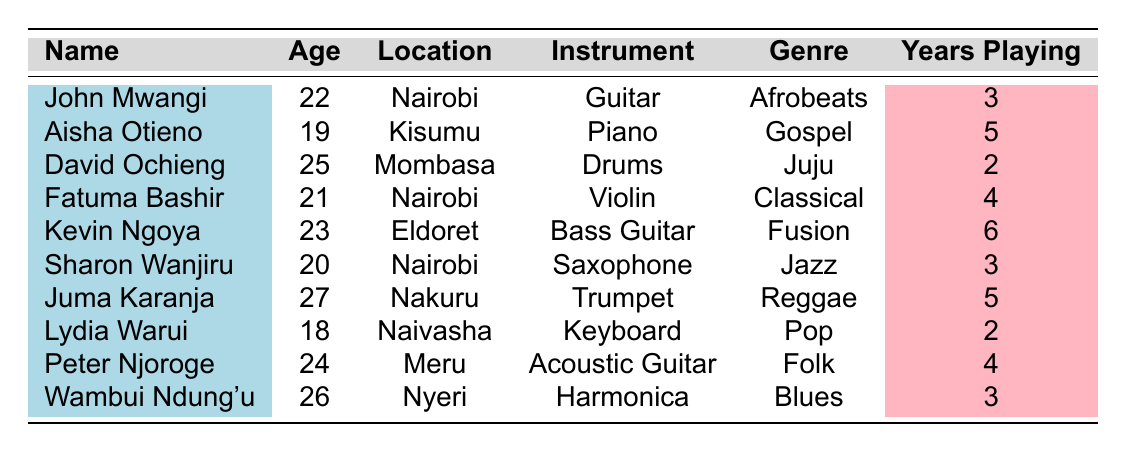What's the most common instrument among amateur musicians listed? By looking at the table, each musician's instrument is identified. The unique instruments mentioned are Guitar, Piano, Drums, Violin, Bass Guitar, Saxophone, Trumpet, Keyboard, Acoustic Guitar, and Harmonica. No instrument is repeated, so none can be deemed common.
Answer: No common instrument What is the age of the youngest musician? The ages of all musicians are listed. The youngest musician is Lydia Warui, who is 18 years old.
Answer: 18 Who has been playing the longest, and for how many years? To find out who has the most years of playing, I will compare the "Years Playing" column. The maximum years playing is 6 by Kevin Ngoya.
Answer: Kevin Ngoya, 6 years Are there any musicians who play wind instruments? Reviewing the instrument column, the musicians who play wind instruments are Sharon Wanjiru (Saxophone) and Juma Karanja (Trumpet). Thus, there are indeed musicians who play wind instruments.
Answer: Yes, there are musicians What percentage of musicians are located in Nairobi? There are four musicians from Nairobi: John Mwangi, Fatuma Bashir, and Sharon Wanjiru. The total number of musicians is 10. The percentage is (4/10) * 100 = 40%.
Answer: 40% What genres do musicians play if they have been playing for 4 or more years? The musicians with 4 or more years of playing are Aisha Otieno (Gospel), Fatuma Bashir (Classical), Kevin Ngoya (Fusion), and Peter Njoroge (Folk). Their genres are Gospel, Classical, Fusion, and Folk.
Answer: Gospel, Classical, Fusion, Folk How many musicians are from locations other than Nairobi? From the list of musicians, the ones located outside Nairobi are Aisha Otieno (Kisumu), David Ochieng (Mombasa), Kevin Ngoya (Eldoret), Juma Karanja (Nakuru), Lydia Warui (Naivasha), and Peter Njoroge (Meru), totaling six musicians.
Answer: 6 musicians Which musician plays an instrument not commonly associated with popular music genres? The musician playing an instrument less commonly associated with popular music is Fatuma Bashir, who plays the Violin. Other musicians play instruments like Guitar or Piano, typical for popular music.
Answer: Fatuma Bashir What is the average age of the musicians listed? To calculate the average age, I will sum all the ages: (22 + 19 + 25 + 21 + 23 + 20 + 27 + 18 + 24 + 26) =  215. Dividing by the number of musicians (10) gives an average of 21.5.
Answer: 21.5 Which genre has the most diversity in instruments? By checking the table, the genres and corresponding instruments are as follows: Afrobeats (Guitar), Gospel (Piano), Juju (Drums), Classical (Violin), Fusion (Bass Guitar), Jazz (Saxophone), Reggae (Trumpet), Pop (Keyboard), Folk (Acoustic Guitar), Blues (Harmonica). Each genre has a unique instrument being played; thus, there's none with varied instruments.
Answer: No genre has diverse instruments Is there a musician aged 25 or older who plays a string instrument? The musicians who are 25 or older are David Ochieng (25, Drums), Kevin Ngoya (23, Bass Guitar), and Wambui Ndung'u (26, Harmonica). The only string instrument mentioned is the Bass Guitar played by Kevin Ngoya, who doesn't meet the age criterion; therefore, there's no musician aged 25 or older who plays a string instrument.
Answer: No 